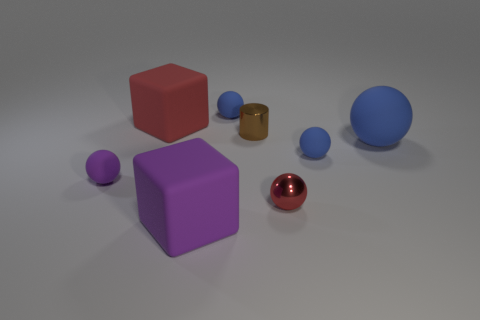How many other objects are the same color as the shiny sphere?
Provide a succinct answer. 1. There is a sphere that is left of the blue sphere on the left side of the tiny shiny thing that is to the left of the tiny red metal sphere; what size is it?
Ensure brevity in your answer.  Small. Are there any rubber things behind the tiny red object?
Provide a short and direct response. Yes. There is a red metallic thing; does it have the same size as the blue rubber object that is on the left side of the tiny brown object?
Provide a short and direct response. Yes. How many other things are there of the same material as the big sphere?
Keep it short and to the point. 5. What shape is the large matte thing that is behind the small red shiny ball and to the left of the tiny metallic cylinder?
Offer a terse response. Cube. Do the shiny thing in front of the big blue ball and the shiny thing that is on the left side of the red shiny object have the same size?
Your answer should be compact. Yes. The tiny purple thing that is made of the same material as the large sphere is what shape?
Keep it short and to the point. Sphere. Is there anything else that has the same shape as the big red rubber thing?
Keep it short and to the point. Yes. What color is the cube on the right side of the large cube behind the brown cylinder to the left of the big rubber ball?
Make the answer very short. Purple. 